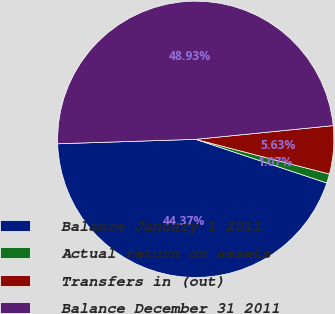<chart> <loc_0><loc_0><loc_500><loc_500><pie_chart><fcel>Balance January 1 2011<fcel>Actual return on assets<fcel>Transfers in (out)<fcel>Balance December 31 2011<nl><fcel>44.37%<fcel>1.07%<fcel>5.63%<fcel>48.93%<nl></chart> 